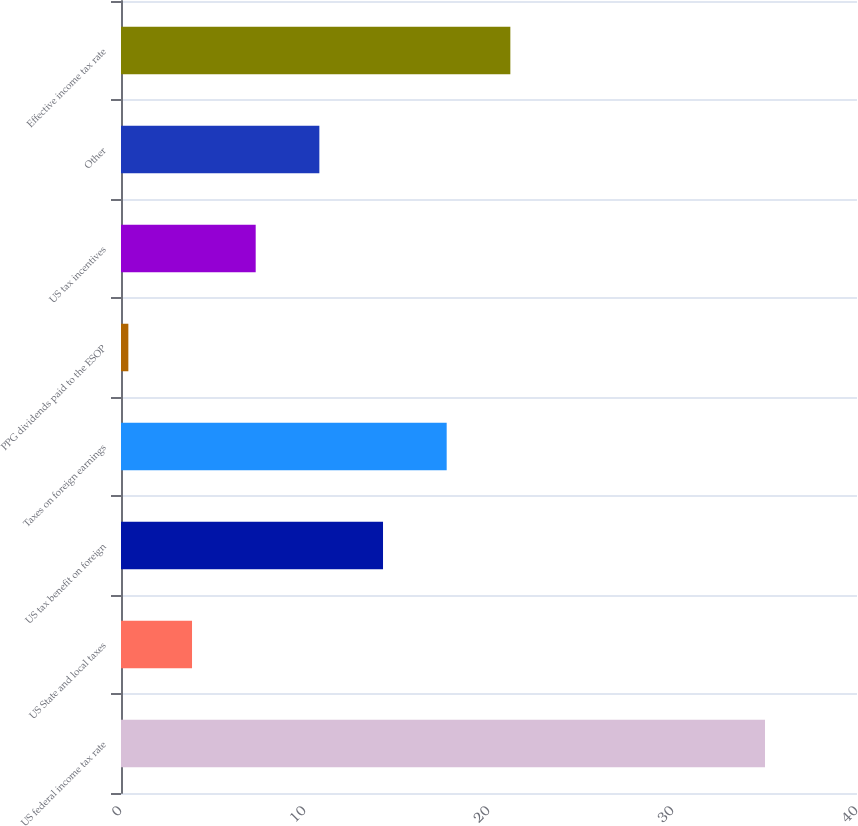Convert chart. <chart><loc_0><loc_0><loc_500><loc_500><bar_chart><fcel>US federal income tax rate<fcel>US State and local taxes<fcel>US tax benefit on foreign<fcel>Taxes on foreign earnings<fcel>PPG dividends paid to the ESOP<fcel>US tax incentives<fcel>Other<fcel>Effective income tax rate<nl><fcel>35<fcel>3.86<fcel>14.24<fcel>17.7<fcel>0.4<fcel>7.32<fcel>10.78<fcel>21.16<nl></chart> 